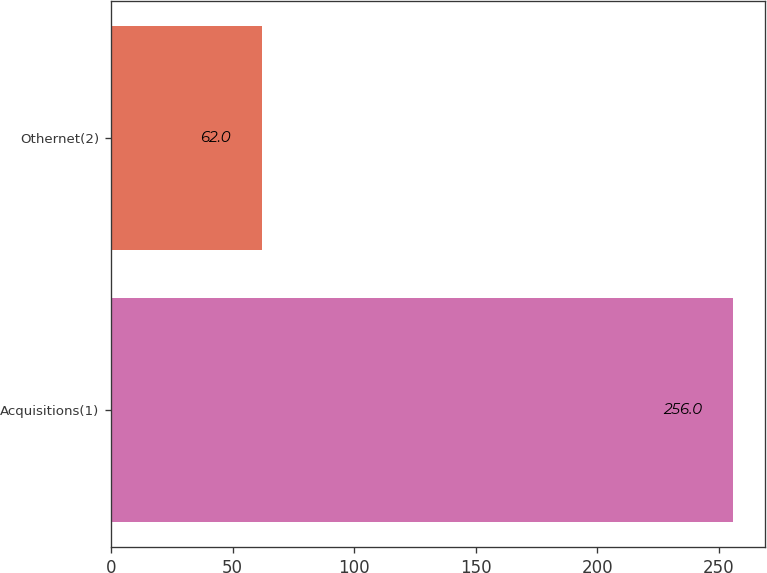<chart> <loc_0><loc_0><loc_500><loc_500><bar_chart><fcel>Acquisitions(1)<fcel>Othernet(2)<nl><fcel>256<fcel>62<nl></chart> 